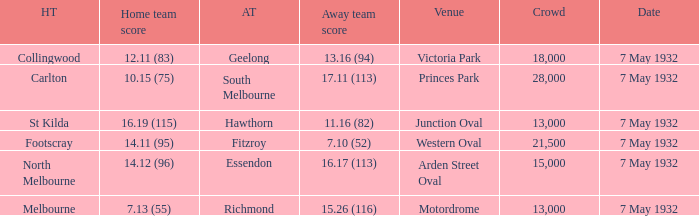Could you parse the entire table as a dict? {'header': ['HT', 'Home team score', 'AT', 'Away team score', 'Venue', 'Crowd', 'Date'], 'rows': [['Collingwood', '12.11 (83)', 'Geelong', '13.16 (94)', 'Victoria Park', '18,000', '7 May 1932'], ['Carlton', '10.15 (75)', 'South Melbourne', '17.11 (113)', 'Princes Park', '28,000', '7 May 1932'], ['St Kilda', '16.19 (115)', 'Hawthorn', '11.16 (82)', 'Junction Oval', '13,000', '7 May 1932'], ['Footscray', '14.11 (95)', 'Fitzroy', '7.10 (52)', 'Western Oval', '21,500', '7 May 1932'], ['North Melbourne', '14.12 (96)', 'Essendon', '16.17 (113)', 'Arden Street Oval', '15,000', '7 May 1932'], ['Melbourne', '7.13 (55)', 'Richmond', '15.26 (116)', 'Motordrome', '13,000', '7 May 1932']]} What is the total of crowd with Home team score of 14.12 (96)? 15000.0. 